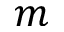<formula> <loc_0><loc_0><loc_500><loc_500>m</formula> 